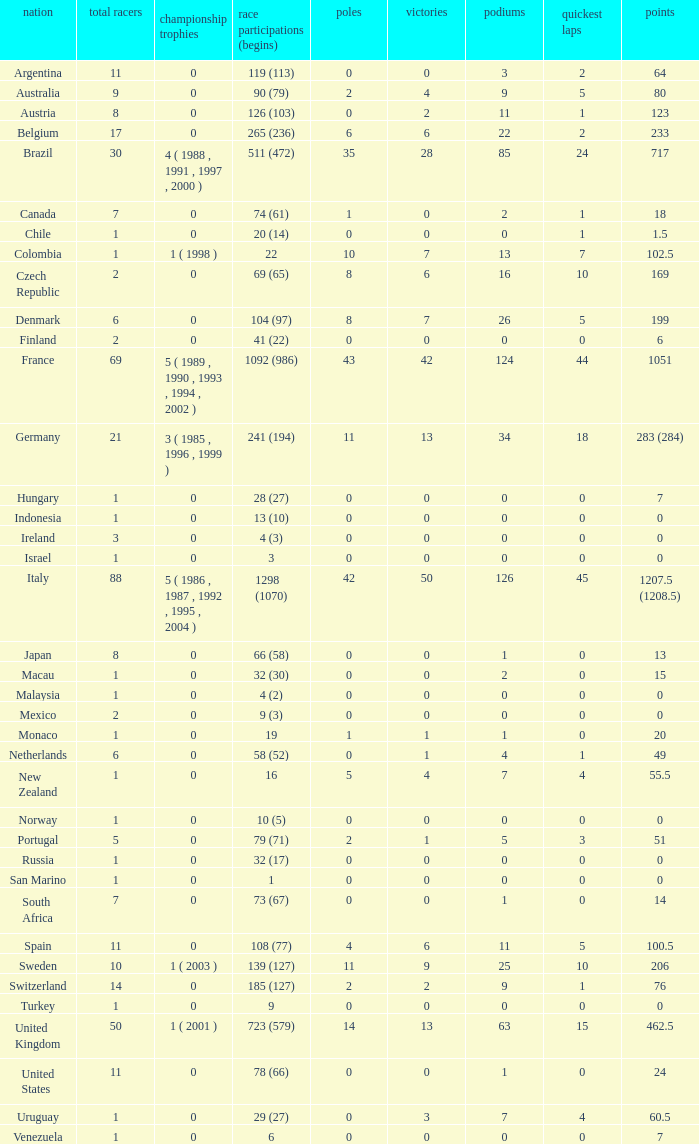How many titles for the nation with less than 3 fastest laps and 22 podiums? 0.0. 